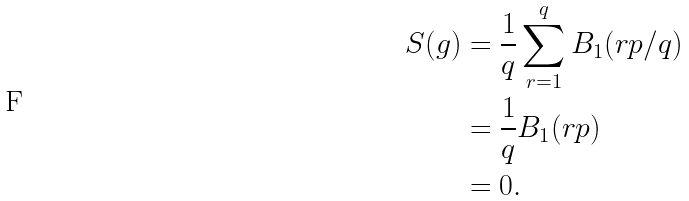Convert formula to latex. <formula><loc_0><loc_0><loc_500><loc_500>S ( g ) & = \frac { 1 } { q } \sum _ { r = 1 } ^ { q } B _ { 1 } ( r p / q ) \\ & = \frac { 1 } { q } B _ { 1 } ( r p ) \\ & = 0 .</formula> 